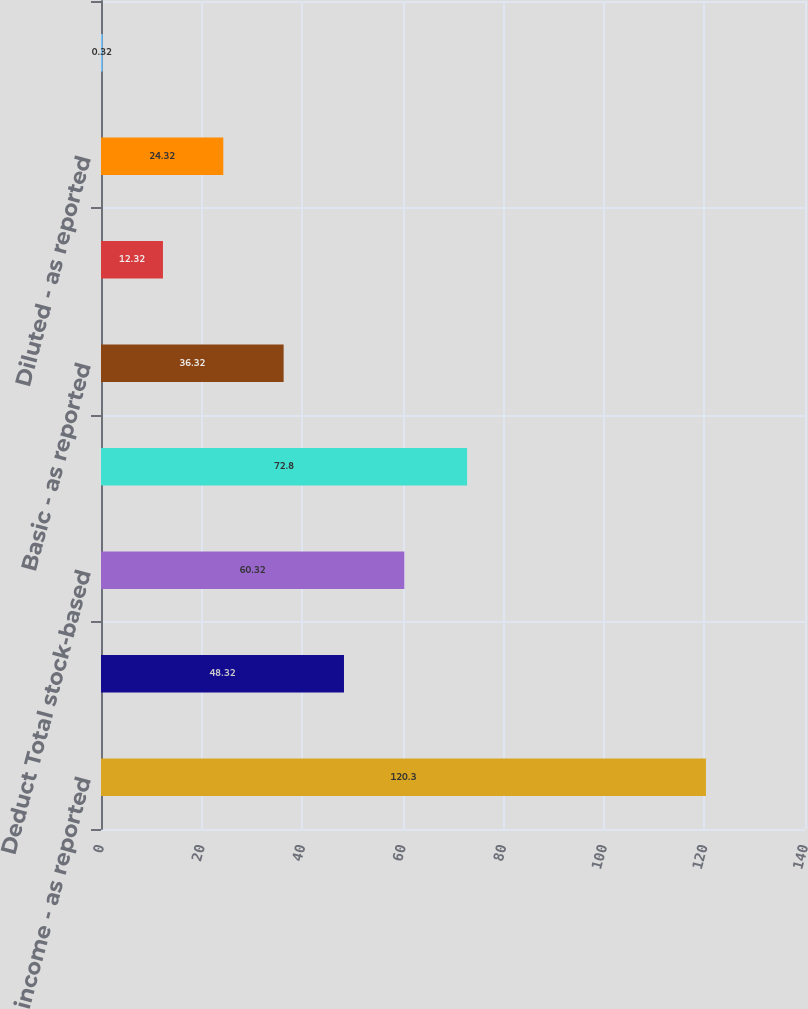Convert chart. <chart><loc_0><loc_0><loc_500><loc_500><bar_chart><fcel>Net income - as reported<fcel>Add Stock-based employee<fcel>Deduct Total stock-based<fcel>Pro forma net income<fcel>Basic - as reported<fcel>Basic - pro forma<fcel>Diluted - as reported<fcel>Diluted - pro forma<nl><fcel>120.3<fcel>48.32<fcel>60.32<fcel>72.8<fcel>36.32<fcel>12.32<fcel>24.32<fcel>0.32<nl></chart> 